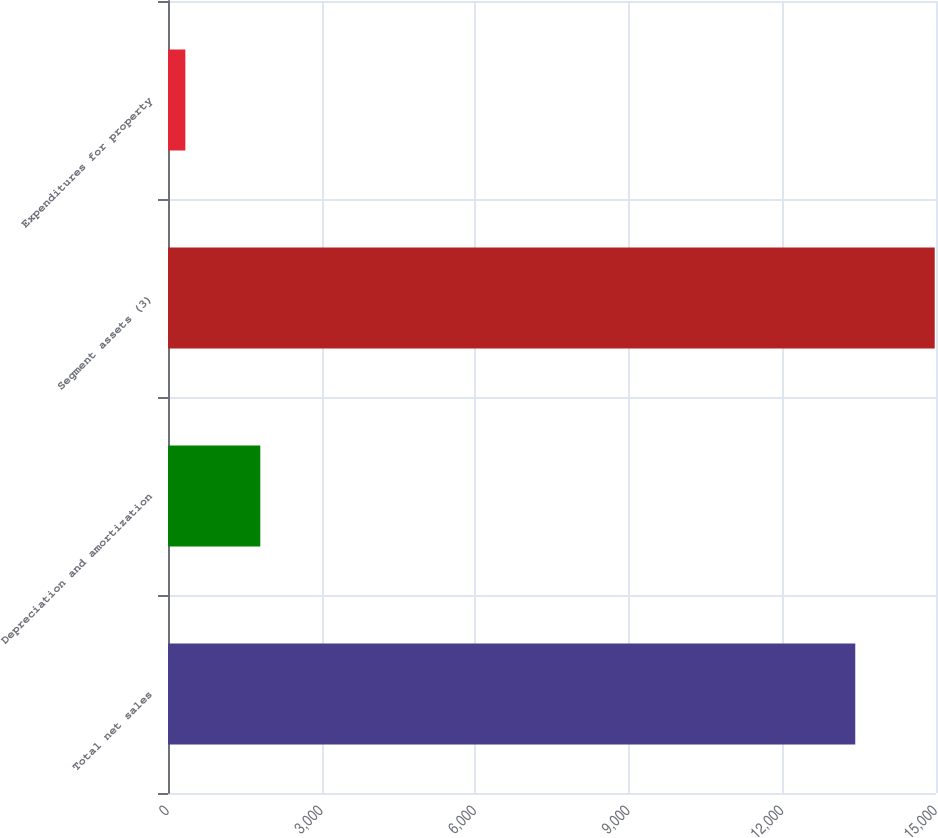Convert chart. <chart><loc_0><loc_0><loc_500><loc_500><bar_chart><fcel>Total net sales<fcel>Depreciation and amortization<fcel>Segment assets (3)<fcel>Expenditures for property<nl><fcel>13423<fcel>1802.6<fcel>14975<fcel>339<nl></chart> 